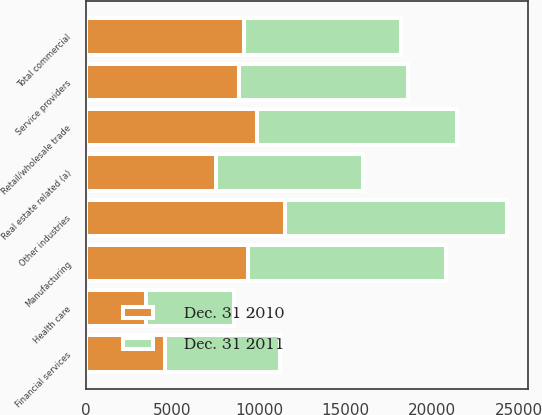Convert chart. <chart><loc_0><loc_0><loc_500><loc_500><stacked_bar_chart><ecel><fcel>Retail/wholesale trade<fcel>Manufacturing<fcel>Service providers<fcel>Real estate related (a)<fcel>Financial services<fcel>Health care<fcel>Other industries<fcel>Total commercial<nl><fcel>Dec. 31 2011<fcel>11539<fcel>11453<fcel>9717<fcel>8488<fcel>6646<fcel>5068<fcel>12783<fcel>9100<nl><fcel>Dec. 31 2010<fcel>9901<fcel>9334<fcel>8866<fcel>7500<fcel>4573<fcel>3481<fcel>11522<fcel>9100<nl></chart> 